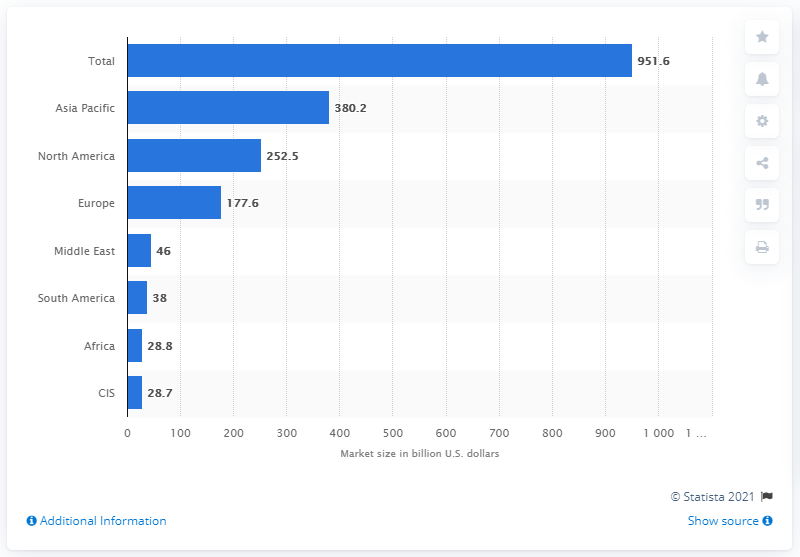Outline some significant characteristics in this image. The third-party logistics market in the United States was valued at approximately 252.5 billion dollars in 2021. 